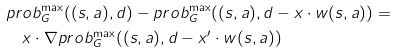Convert formula to latex. <formula><loc_0><loc_0><loc_500><loc_500>& p r o b ^ { \max } _ { G } ( ( s , a ) , d ) - p r o b ^ { \max } _ { G } ( ( s , a ) , d - x \cdot w ( s , a ) ) = \\ & \quad x \cdot \nabla p r o b _ { G } ^ { \max } ( ( s , a ) , d - x ^ { \prime } \cdot w ( s , a ) )</formula> 